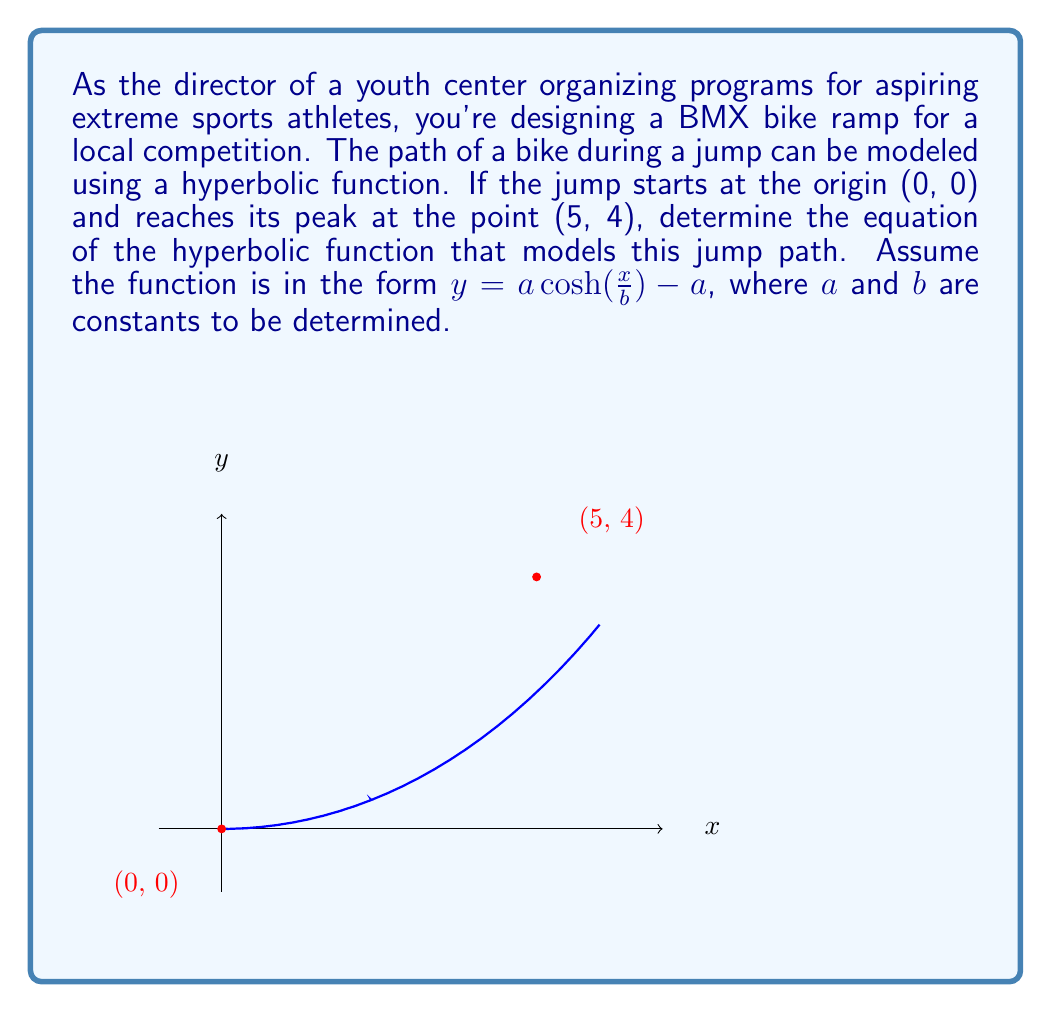Provide a solution to this math problem. Let's approach this step-by-step:

1) We're given that the hyperbolic function is in the form:
   $y = a \cosh(\frac{x}{b}) - a$

2) We know two points on this curve:
   (0, 0) and (5, 4)

3) Let's use the point (0, 0) first:
   $0 = a \cosh(\frac{0}{b}) - a$
   $0 = a(1) - a = 0$
   This is always true, so it doesn't give us any new information.

4) Now, let's use the point (5, 4):
   $4 = a \cosh(\frac{5}{b}) - a$

5) We can rewrite this as:
   $\frac{4+a}{a} = \cosh(\frac{5}{b})$

6) The inverse of cosh is arccosh, so:
   $\frac{5}{b} = \text{arccosh}(\frac{4+a}{a})$

7) Now we have:
   $b = \frac{5}{\text{arccosh}(\frac{4+a}{a})}$

8) We need another equation to solve for $a$ and $b$. We can use the fact that the derivative of our function at x=5 should be zero (since it's the peak of the jump).

9) The derivative of $y = a \cosh(\frac{x}{b}) - a$ is:
   $y' = \frac{a}{b} \sinh(\frac{x}{b})$

10) Setting this to zero at x=5:
    $0 = \frac{a}{b} \sinh(\frac{5}{b})$

11) This is only true if $a=0$ (which isn't the case here) or if $\frac{5}{b} = 0$, which means $b$ must approach infinity.

12) As $b$ approaches infinity, $\frac{5}{b}$ approaches 0, and $\cosh(0) = 1$

13) From step 5, as $b$ approaches infinity:
    $\frac{4+a}{a} = 1$
    $4+a = a$
    $4 = 0$

14) This is impossible, so our initial assumption that the peak occurs exactly at (5,4) must be slightly off due to the nature of the hyperbolic cosine function.

15) We can approximate the solution by choosing a very large value for $b$, say $b=100$. Then:

    $\frac{4+a}{a} = \cosh(\frac{5}{100}) \approx 1.00125$

    Solving this:
    $4+a = 1.00125a$
    $4 = 0.00125a$
    $a = 3200$

16) Therefore, our approximation of the function is:
    $y = 3200 \cosh(\frac{x}{100}) - 3200$
Answer: $y \approx 3200 \cosh(\frac{x}{100}) - 3200$ 